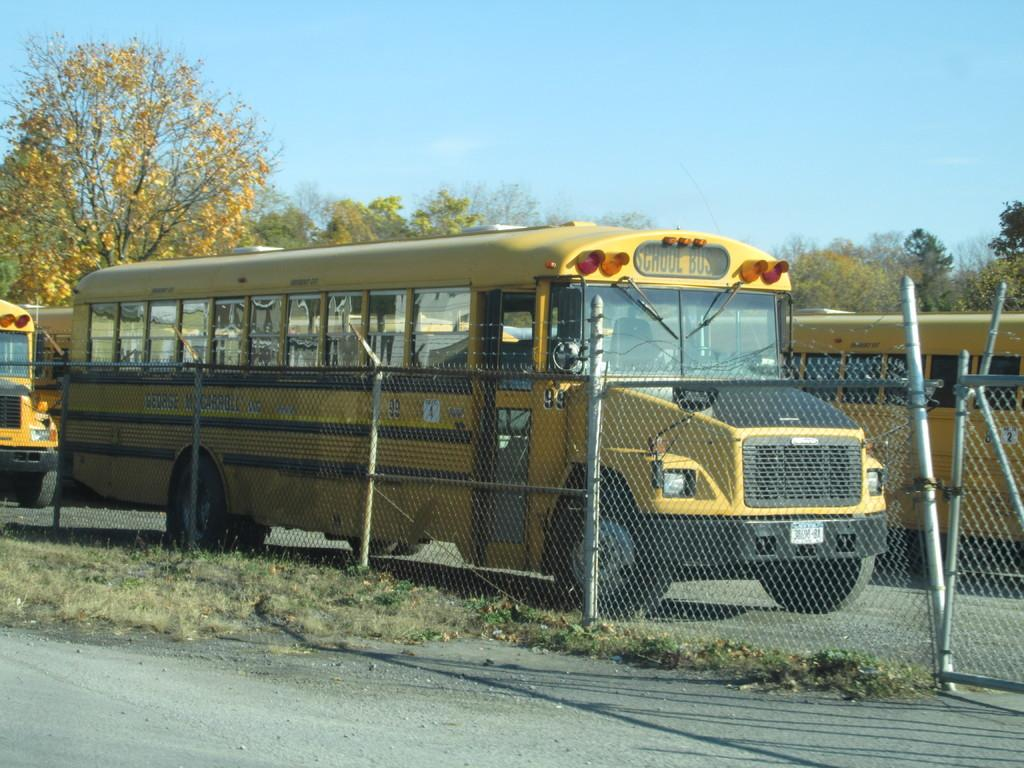<image>
Render a clear and concise summary of the photo. The school bus on the front left has a white sign with the number 4. 